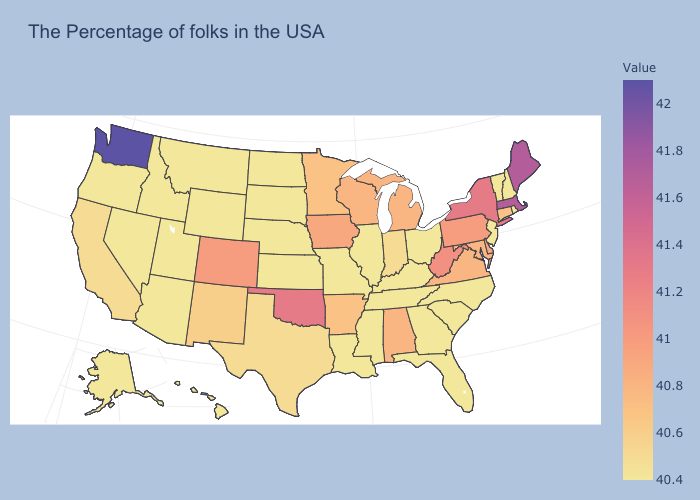Is the legend a continuous bar?
Quick response, please. Yes. Which states have the lowest value in the Northeast?
Keep it brief. Rhode Island, New Hampshire, Vermont, New Jersey. Which states have the lowest value in the West?
Give a very brief answer. Wyoming, Utah, Montana, Arizona, Idaho, Nevada, Oregon, Alaska, Hawaii. Which states have the highest value in the USA?
Concise answer only. Washington. Among the states that border Oklahoma , which have the highest value?
Be succinct. Colorado. Is the legend a continuous bar?
Keep it brief. Yes. 